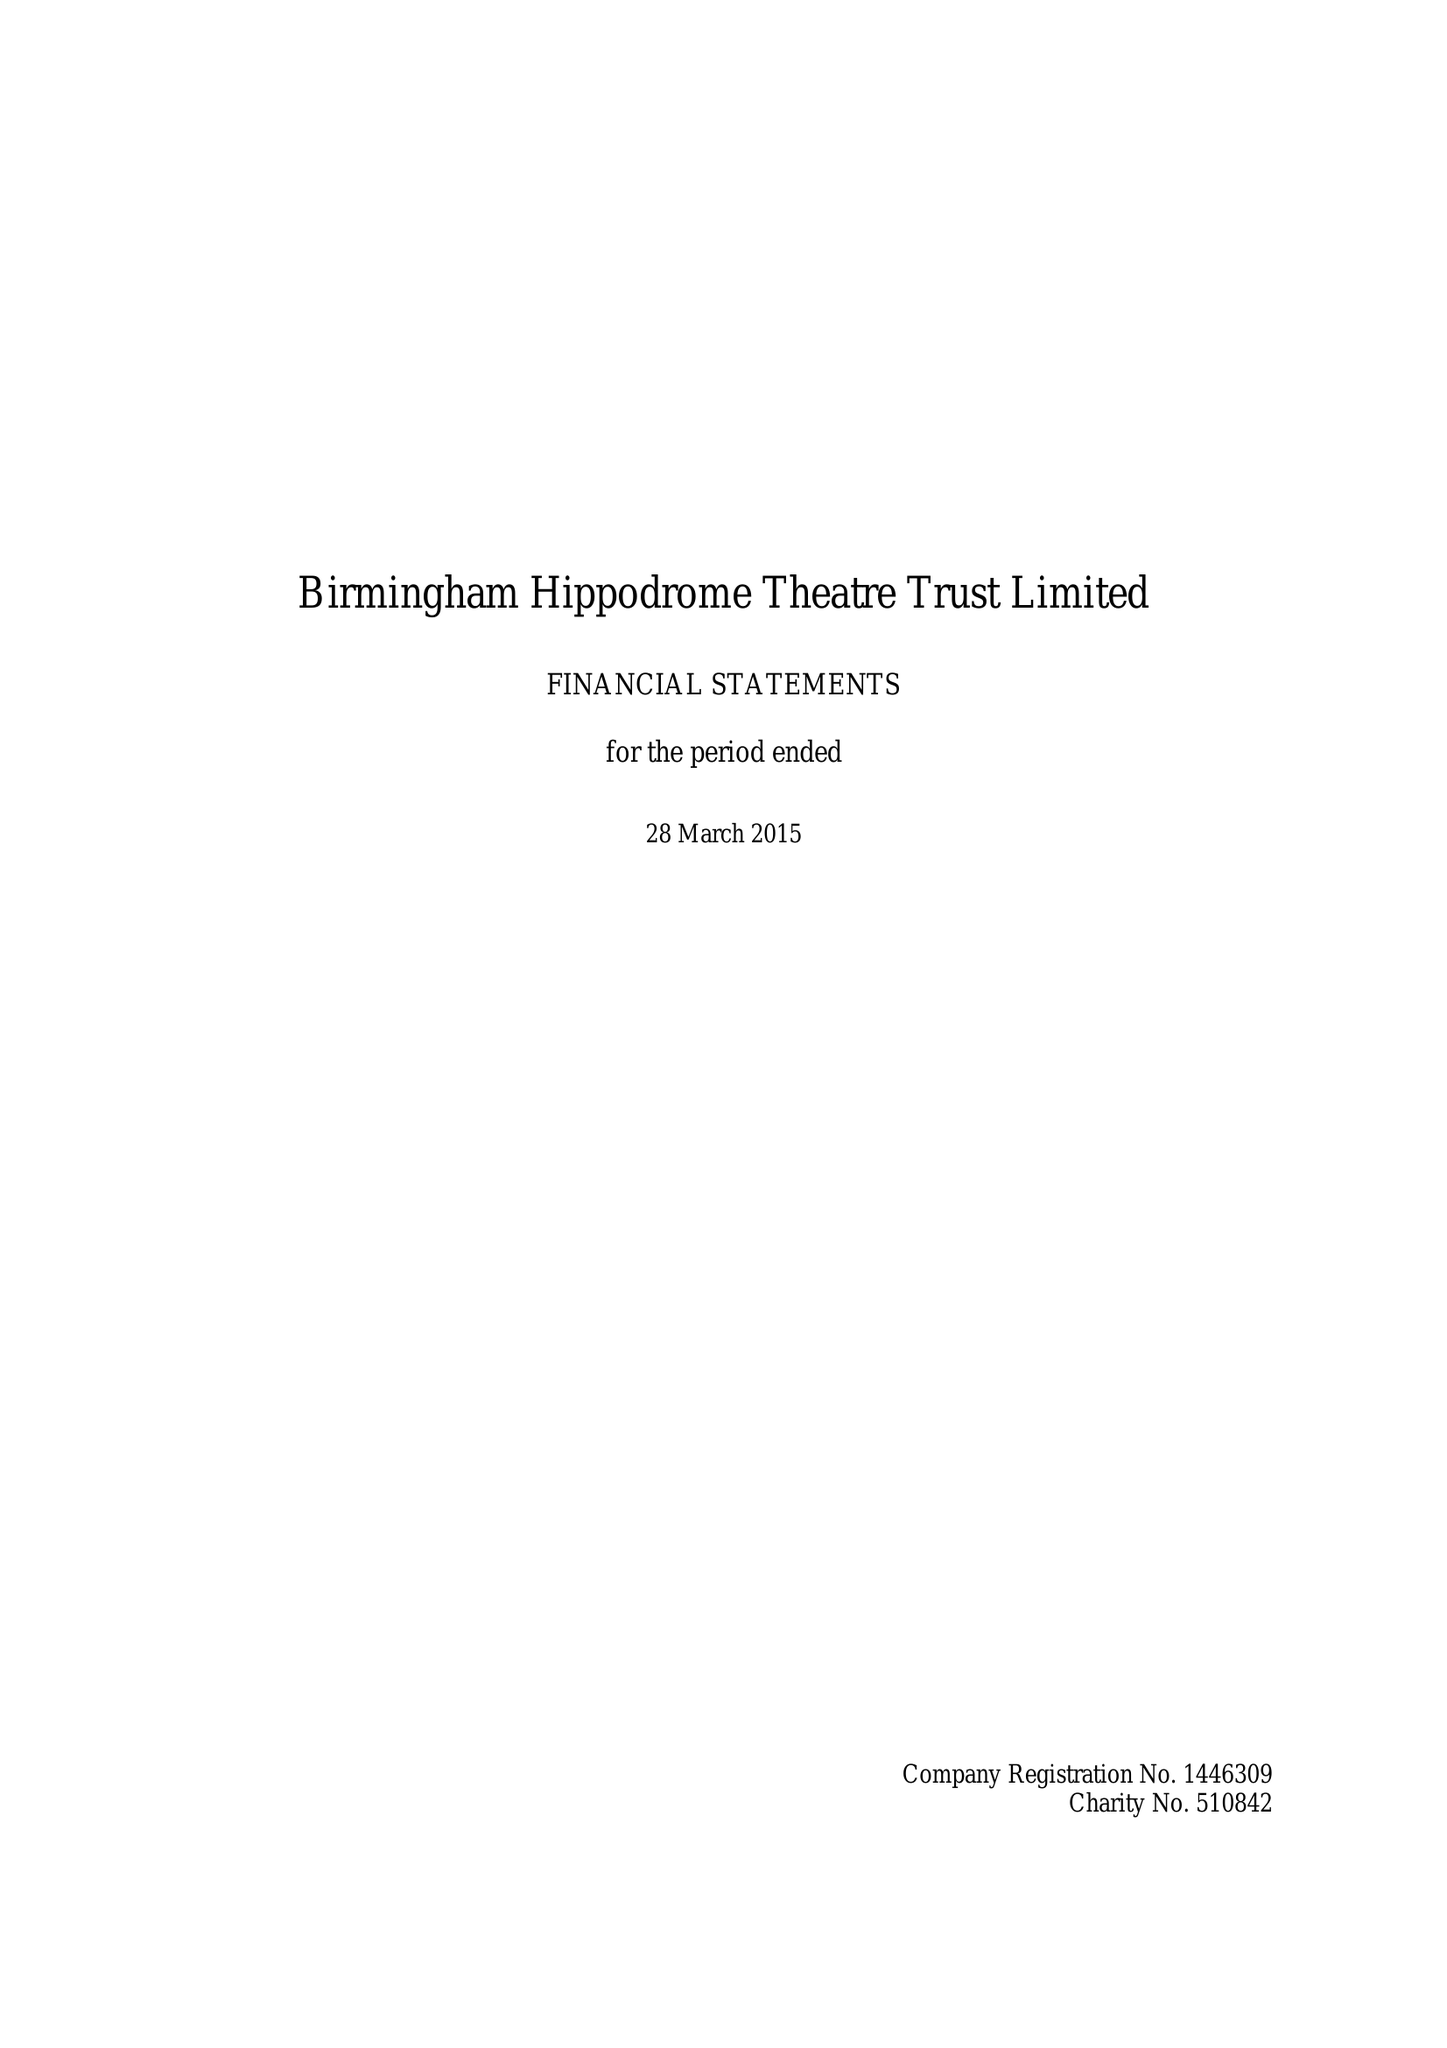What is the value for the report_date?
Answer the question using a single word or phrase. 2015-03-28 